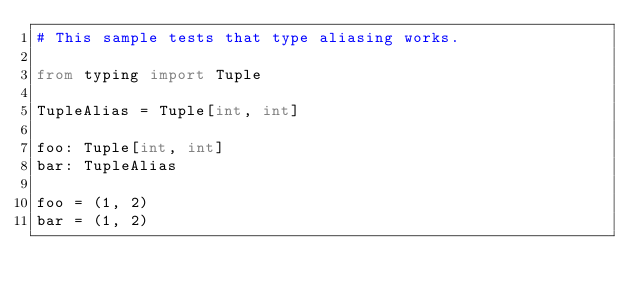Convert code to text. <code><loc_0><loc_0><loc_500><loc_500><_Python_># This sample tests that type aliasing works.

from typing import Tuple

TupleAlias = Tuple[int, int]

foo: Tuple[int, int]
bar: TupleAlias

foo = (1, 2)
bar = (1, 2)



</code> 